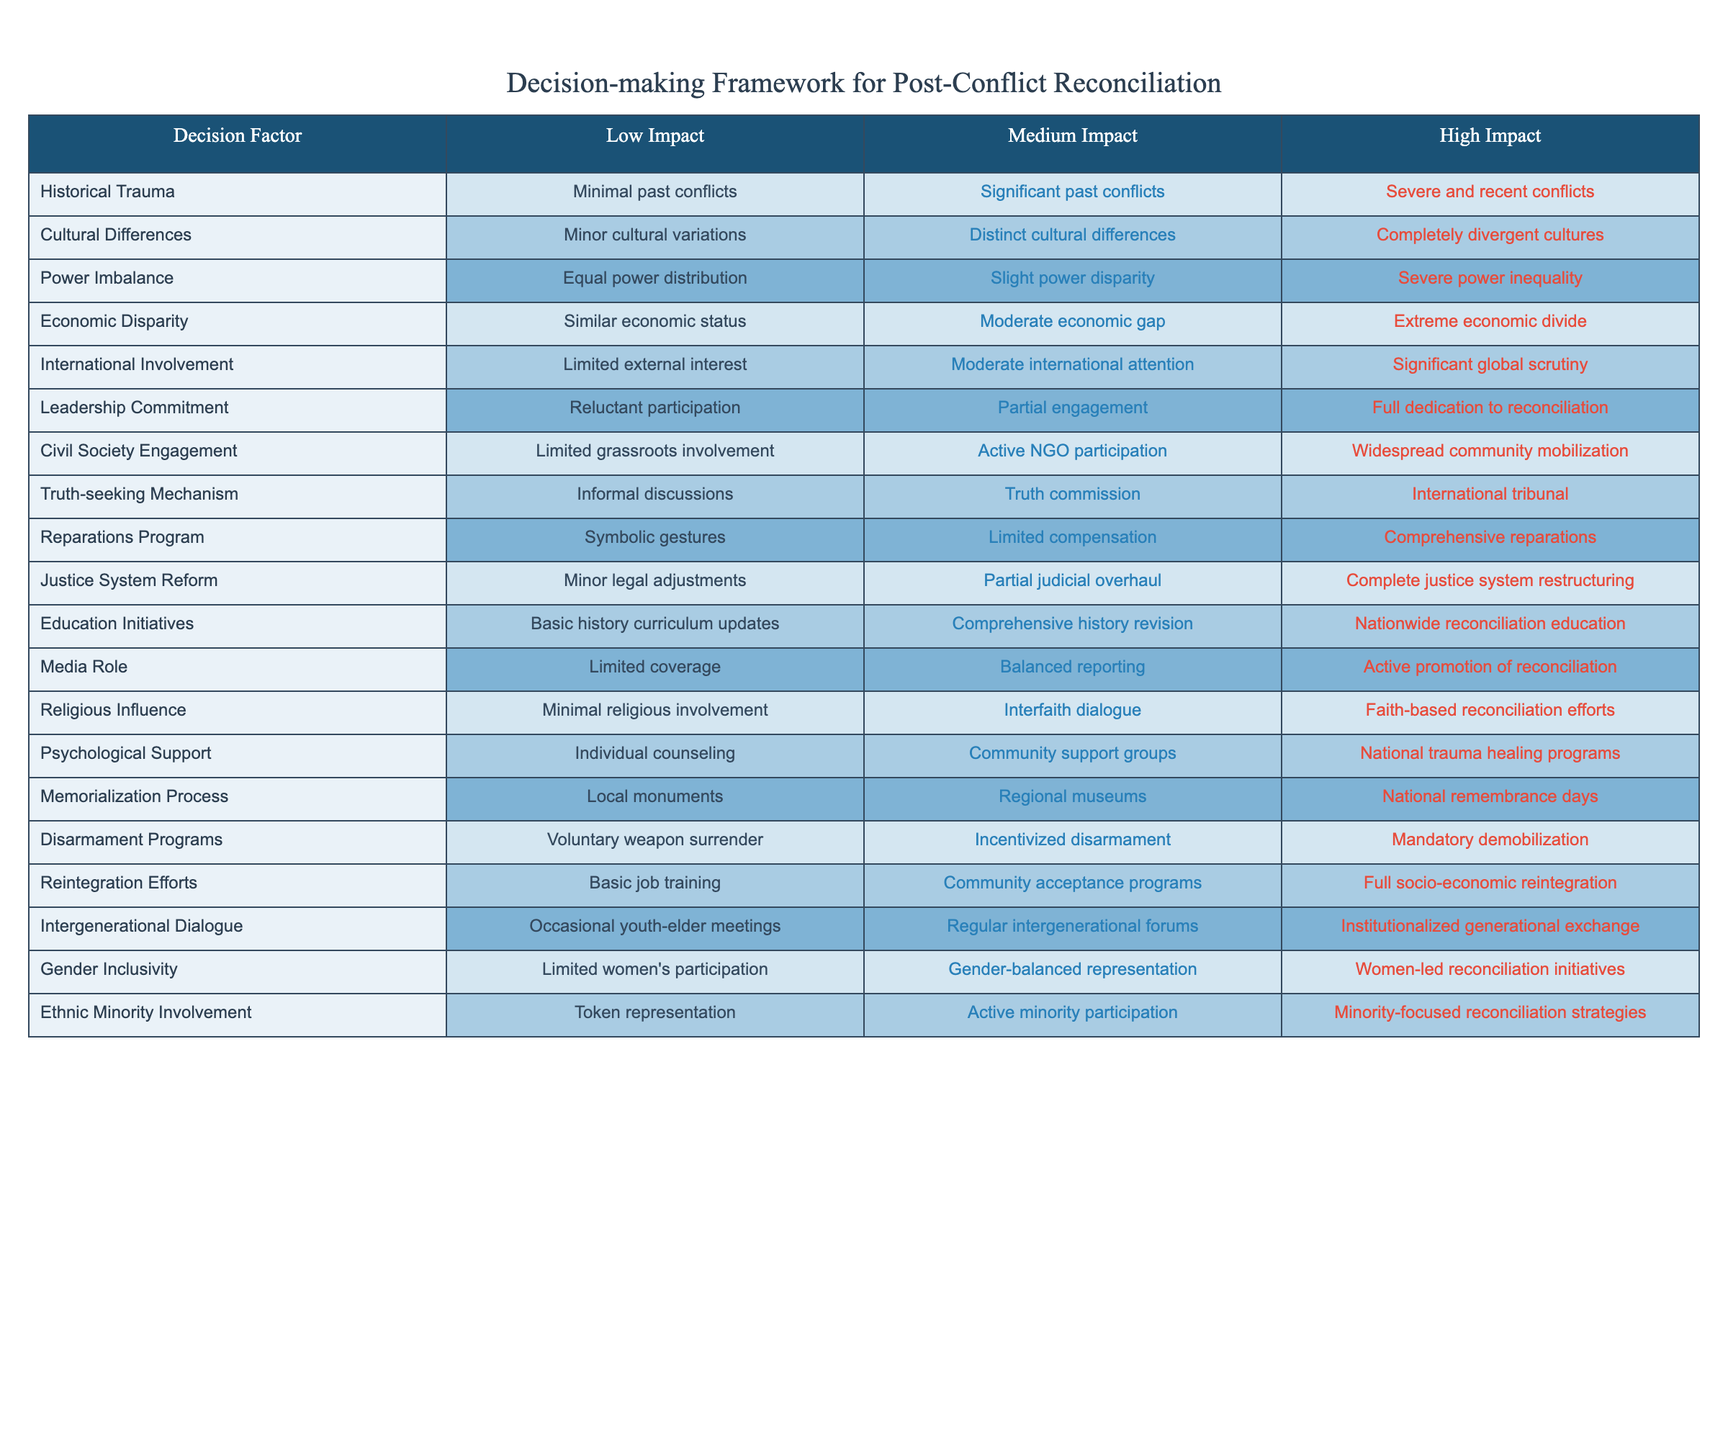What is the highest level of impact for Historical Trauma? According to the table, the highest level of impact for Historical Trauma is "Severe and recent conflicts." This can be verified in the row titled "Historical Trauma" under the "High Impact" column.
Answer: Severe and recent conflicts Which decision factor has full dedication to reconciliation as the high impact category? The decision factor that has "Full dedication to reconciliation" listed under the high impact category is "Leadership Commitment." This information is found in the row for Leadership Commitment under the High Impact column.
Answer: Leadership Commitment Is there a decision factor where the low impact category includes "Similar economic status"? Yes, the decision factor "Economic Disparity" lists "Similar economic status" under the low impact category. This can be confirmed by checking the relevant row in the table.
Answer: Yes What are the potential impacts of International Involvement? "International Involvement" can have three potential impacts: Limited external interest (Low), Moderate international attention (Medium), and Significant global scrutiny (High). Each of these impacts is categorized in the respective columns of the table.
Answer: Limited external interest, Moderate international attention, Significant global scrutiny For Civil Society Engagement, what is the difference in impact between Limited grassroots involvement and Widespread community mobilization? The difference in impact between "Limited grassroots involvement" (Low impact) and "Widespread community mobilization" (High impact) is significant, indicating that as the level of grassroots involvement increases from low to high, the overall engagement in reconciliation processes also improves considerably. This reflects a move from minimal to extensive community engagement as indicated in the requests.
Answer: Significant increase in engagement How many of the decision factors have a high impact category explicitly stating a mechanism for truth-seeking? Only one decision factor explicitly states a mechanism for truth-seeking in the high impact category, which is "International tribunal" under the "Truth-seeking Mechanism." This distinguishes it from other factors that may focus on practices or adjustments without specifying a formal mechanism.
Answer: One For Gender Inclusivity, how many levels are listed and what are they? The levels listed for Gender Inclusivity are three: Limited women's participation (Low impact), Gender-balanced representation (Medium impact), and Women-led reconciliation initiatives (High impact). Each level reflects a different degree of women's involvement in the reconciliation process.
Answer: Three levels: Limited women's participation, Gender-balanced representation, Women-led reconciliation initiatives Considering the impacts of Psychological Support, which is the most robust option? The most robust option within the Psychological Support category is "National trauma healing programs" classified as high impact. This shows that when psychological support is addressed at a national level, it potentially has the greatest effect on reconciliation post-conflict.
Answer: National trauma healing programs 